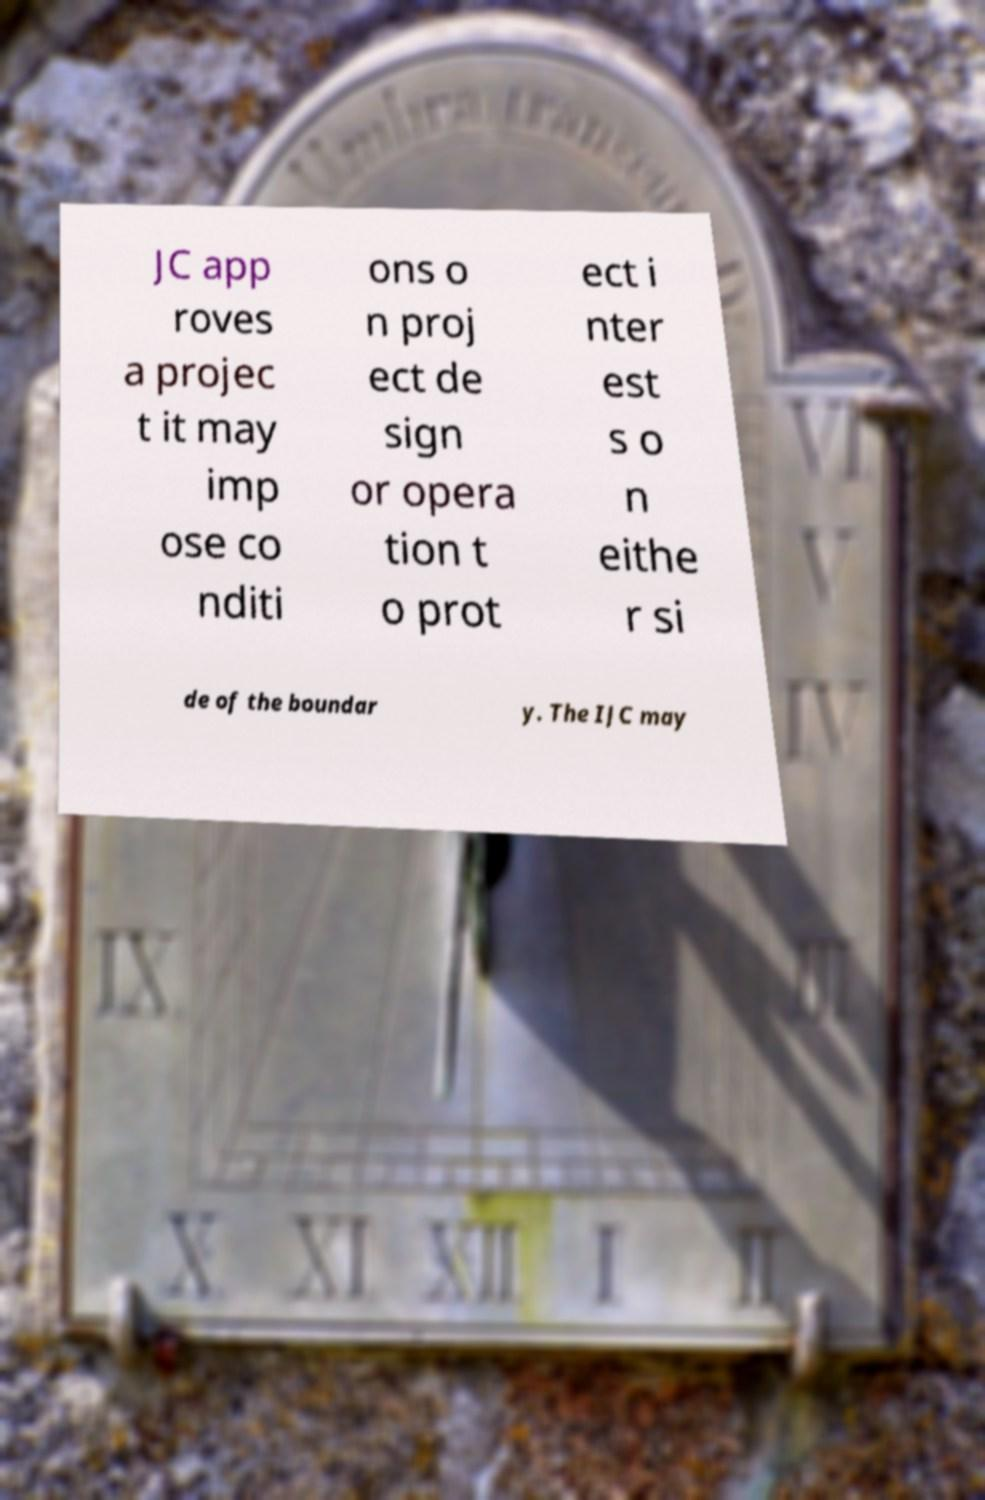Could you assist in decoding the text presented in this image and type it out clearly? JC app roves a projec t it may imp ose co nditi ons o n proj ect de sign or opera tion t o prot ect i nter est s o n eithe r si de of the boundar y. The IJC may 